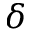<formula> <loc_0><loc_0><loc_500><loc_500>\delta</formula> 